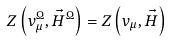<formula> <loc_0><loc_0><loc_500><loc_500>Z \left ( v _ { \mu } ^ { \Omega } , \vec { H } ^ { \Omega } \right ) = Z \left ( v _ { \mu } , \vec { H } \right )</formula> 